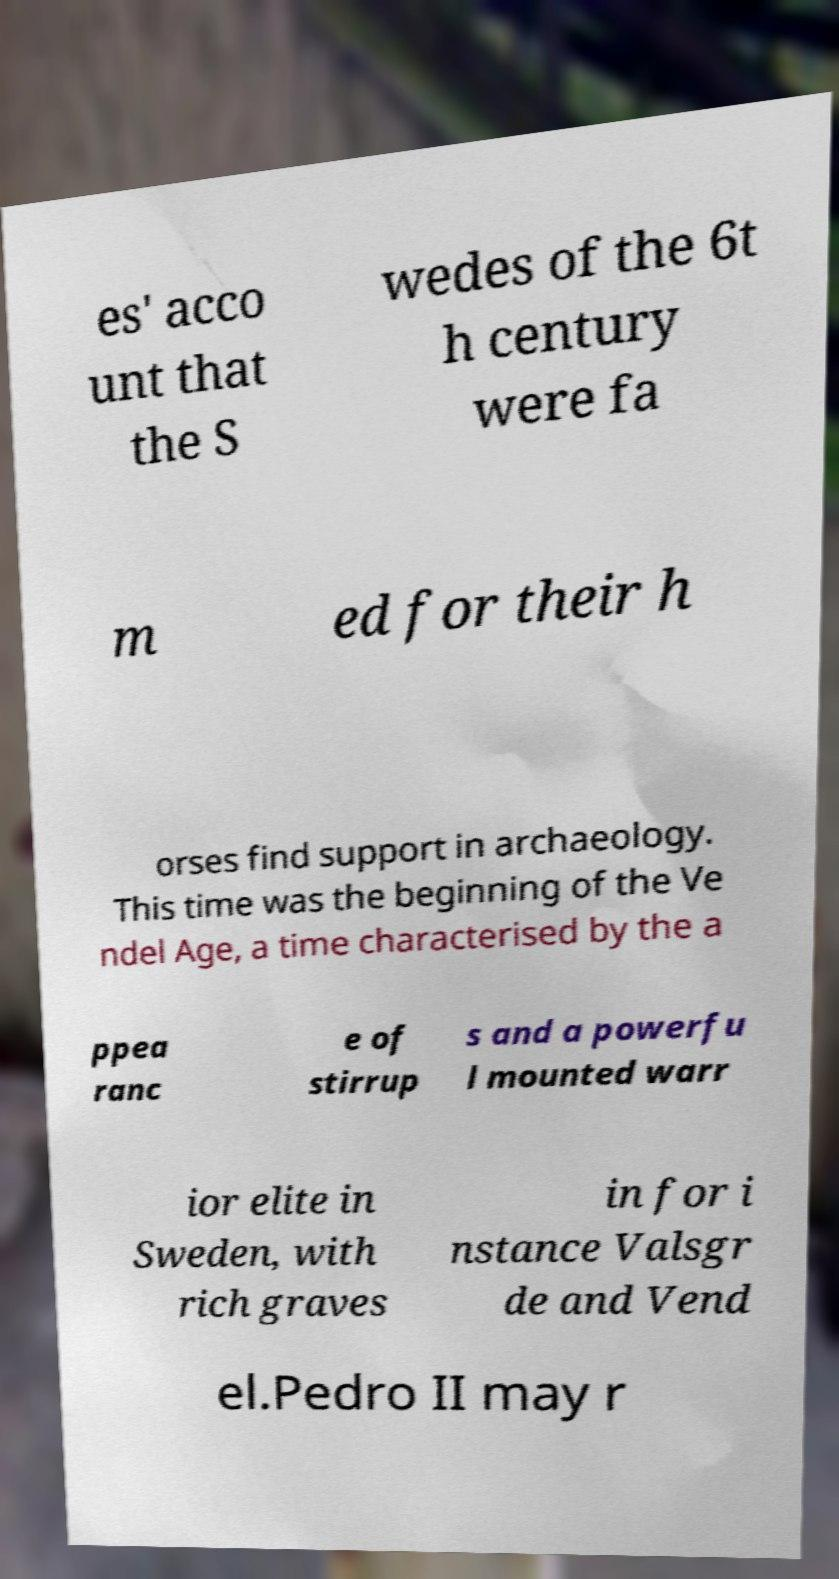Please read and relay the text visible in this image. What does it say? es' acco unt that the S wedes of the 6t h century were fa m ed for their h orses find support in archaeology. This time was the beginning of the Ve ndel Age, a time characterised by the a ppea ranc e of stirrup s and a powerfu l mounted warr ior elite in Sweden, with rich graves in for i nstance Valsgr de and Vend el.Pedro II may r 